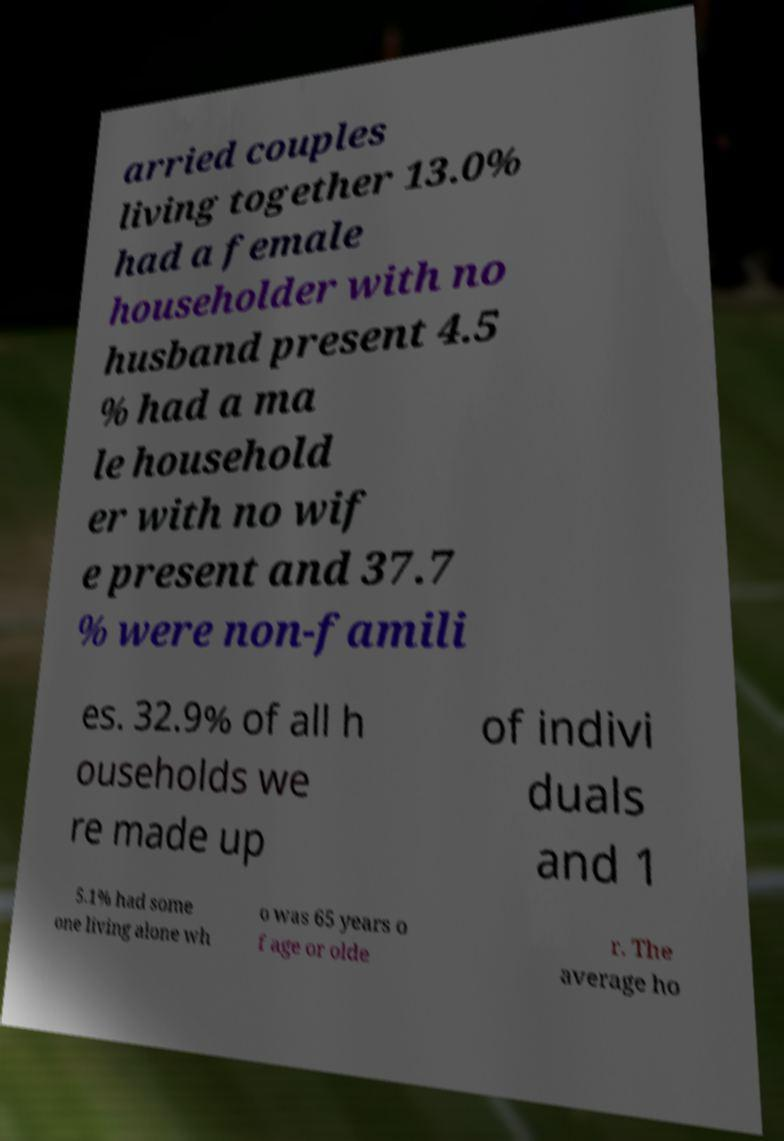Could you extract and type out the text from this image? arried couples living together 13.0% had a female householder with no husband present 4.5 % had a ma le household er with no wif e present and 37.7 % were non-famili es. 32.9% of all h ouseholds we re made up of indivi duals and 1 5.1% had some one living alone wh o was 65 years o f age or olde r. The average ho 